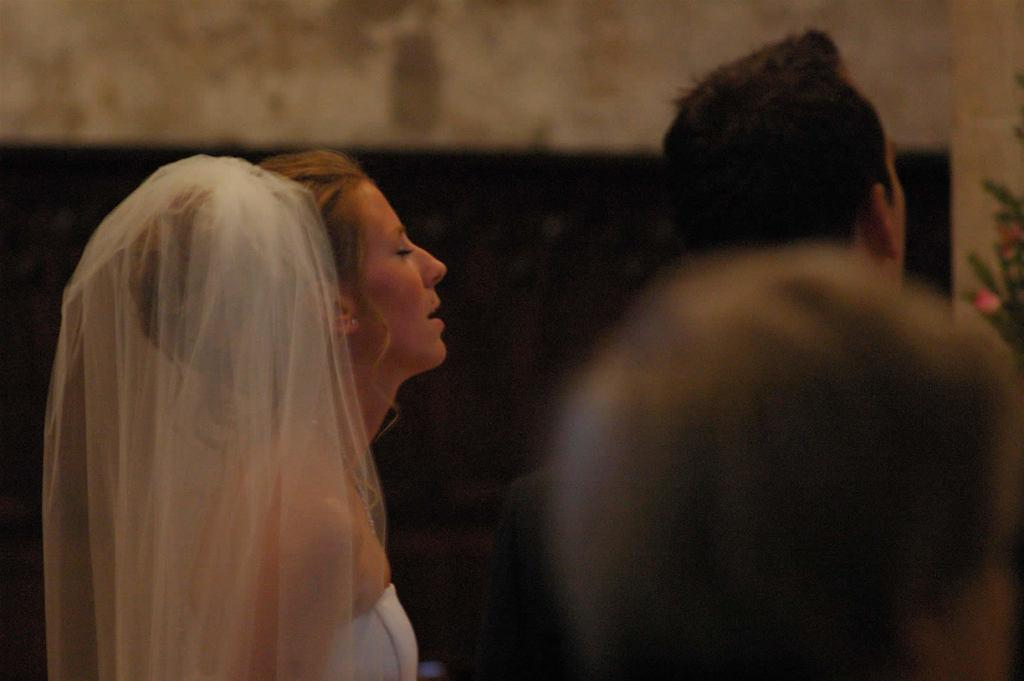Who is the main subject in the image? There is a woman in the image. How many other people are present in the image? There are two other persons in the image. What is the woman wearing? The woman is wearing a white dress. In which direction are the people facing? The people are facing towards the right side. What can be seen in the background of the image? There is a wall in the background of the image. What type of brush is being used to prepare dinner in the image? There is no brush or dinner preparation visible in the image. 